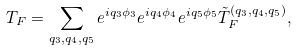<formula> <loc_0><loc_0><loc_500><loc_500>T _ { F } = \sum _ { q _ { 3 } , q _ { 4 } , q _ { 5 } } e ^ { i q _ { 3 } \phi _ { 3 } } e ^ { i q _ { 4 } \phi _ { 4 } } e ^ { i q _ { 5 } \phi _ { 5 } } \tilde { T } _ { F } ^ { ( q _ { 3 } , q _ { 4 } , q _ { 5 } ) } ,</formula> 